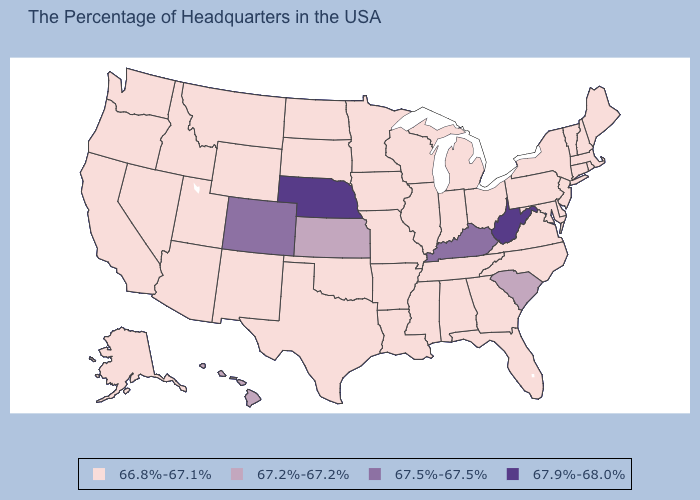Among the states that border North Carolina , does Tennessee have the highest value?
Keep it brief. No. Is the legend a continuous bar?
Write a very short answer. No. What is the value of North Dakota?
Give a very brief answer. 66.8%-67.1%. Does the map have missing data?
Short answer required. No. What is the lowest value in the South?
Write a very short answer. 66.8%-67.1%. What is the highest value in states that border New Jersey?
Quick response, please. 66.8%-67.1%. What is the lowest value in the MidWest?
Write a very short answer. 66.8%-67.1%. Is the legend a continuous bar?
Be succinct. No. Does New Hampshire have the same value as Missouri?
Quick response, please. Yes. How many symbols are there in the legend?
Concise answer only. 4. Does the first symbol in the legend represent the smallest category?
Give a very brief answer. Yes. Does Colorado have the lowest value in the West?
Concise answer only. No. Name the states that have a value in the range 67.9%-68.0%?
Short answer required. West Virginia, Nebraska. Name the states that have a value in the range 67.9%-68.0%?
Short answer required. West Virginia, Nebraska. What is the highest value in states that border North Dakota?
Concise answer only. 66.8%-67.1%. 